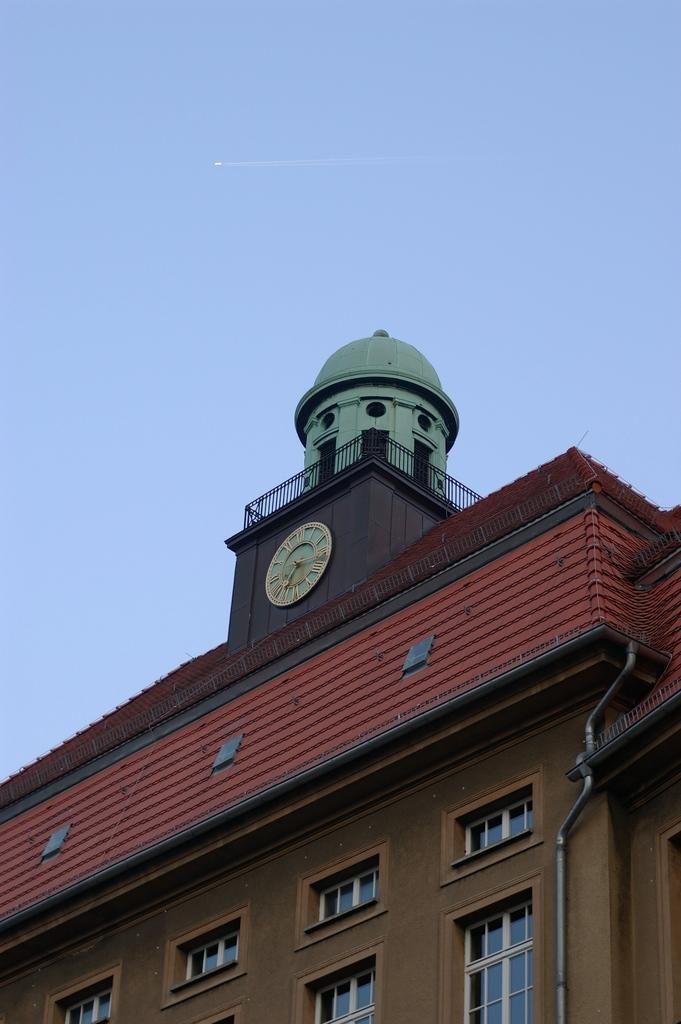What is the main object in the center of the image? There is a clock in the center of the image. What type of structure is present in the image? There is a building in the image. What features can be observed on the building? The building has windows and grills. What is visible at the top of the image? The sky is visible at the top of the image. What type of caption is written on the clock in the image? There is no caption written on the clock in the image. Can you see any clams on the building in the image? There are no clams present in the image. 